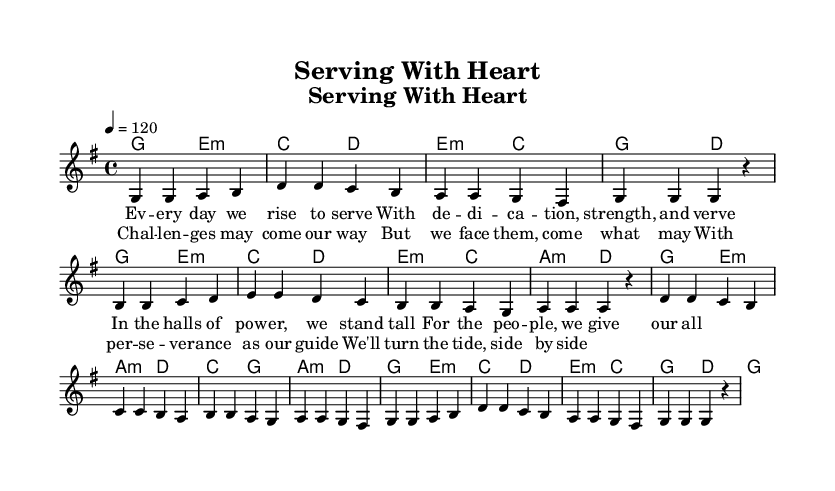What is the key signature of this music? The key signature is G major, which has one sharp (F♯). This can be determined by looking at the key signature indicated at the beginning of the staff.
Answer: G major What is the time signature of the piece? The time signature is 4/4, which separates the measures as there are four beats in each measure. This is indicated at the beginning of the staff.
Answer: 4/4 What is the tempo marking of the piece? The tempo marking indicates a speed of 120 beats per minute, shown at the beginning of the score. This helps establish the feel and energy of the song.
Answer: 120 How many verses are present in the lyrics? The rendered sheet music contains two distinct verses, which are labeled as verse one and verse two. This can be confirmed by counting the pairs of lyrics under the melody.
Answer: 2 What musical form does this song follow based on the lyrics? The song follows a verse format, presenting relevant lyrics that address perseverance and dedication, typical in pop songs. This can be inferred from the separate sections of lyrics in the score.
Answer: Verse What is the primary theme of the lyrics? The primary theme revolves around perseverance and dedication in public service, highlighted through the uplifting lyrics. This theme is evident in the phrases used in both verses, emphasizing commitment and facing challenges.
Answer: Perseverance and dedication How are the chords structured in the song? The chords follow a common pop harmonic progression, with patterns suggesting a call-and-response between the melody and harmony, which is typical for uplifting pop songs. This can be observed in the chord progression listed alongside the melody.
Answer: Common pop harmonic progression 